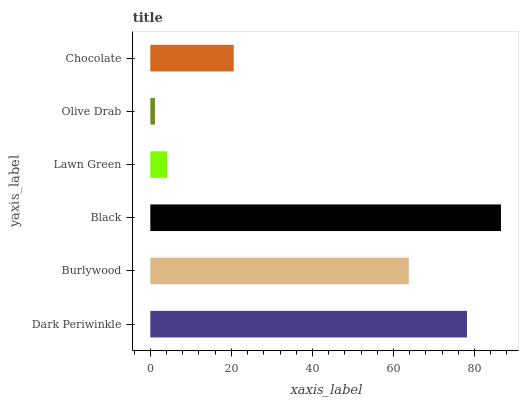Is Olive Drab the minimum?
Answer yes or no. Yes. Is Black the maximum?
Answer yes or no. Yes. Is Burlywood the minimum?
Answer yes or no. No. Is Burlywood the maximum?
Answer yes or no. No. Is Dark Periwinkle greater than Burlywood?
Answer yes or no. Yes. Is Burlywood less than Dark Periwinkle?
Answer yes or no. Yes. Is Burlywood greater than Dark Periwinkle?
Answer yes or no. No. Is Dark Periwinkle less than Burlywood?
Answer yes or no. No. Is Burlywood the high median?
Answer yes or no. Yes. Is Chocolate the low median?
Answer yes or no. Yes. Is Black the high median?
Answer yes or no. No. Is Black the low median?
Answer yes or no. No. 